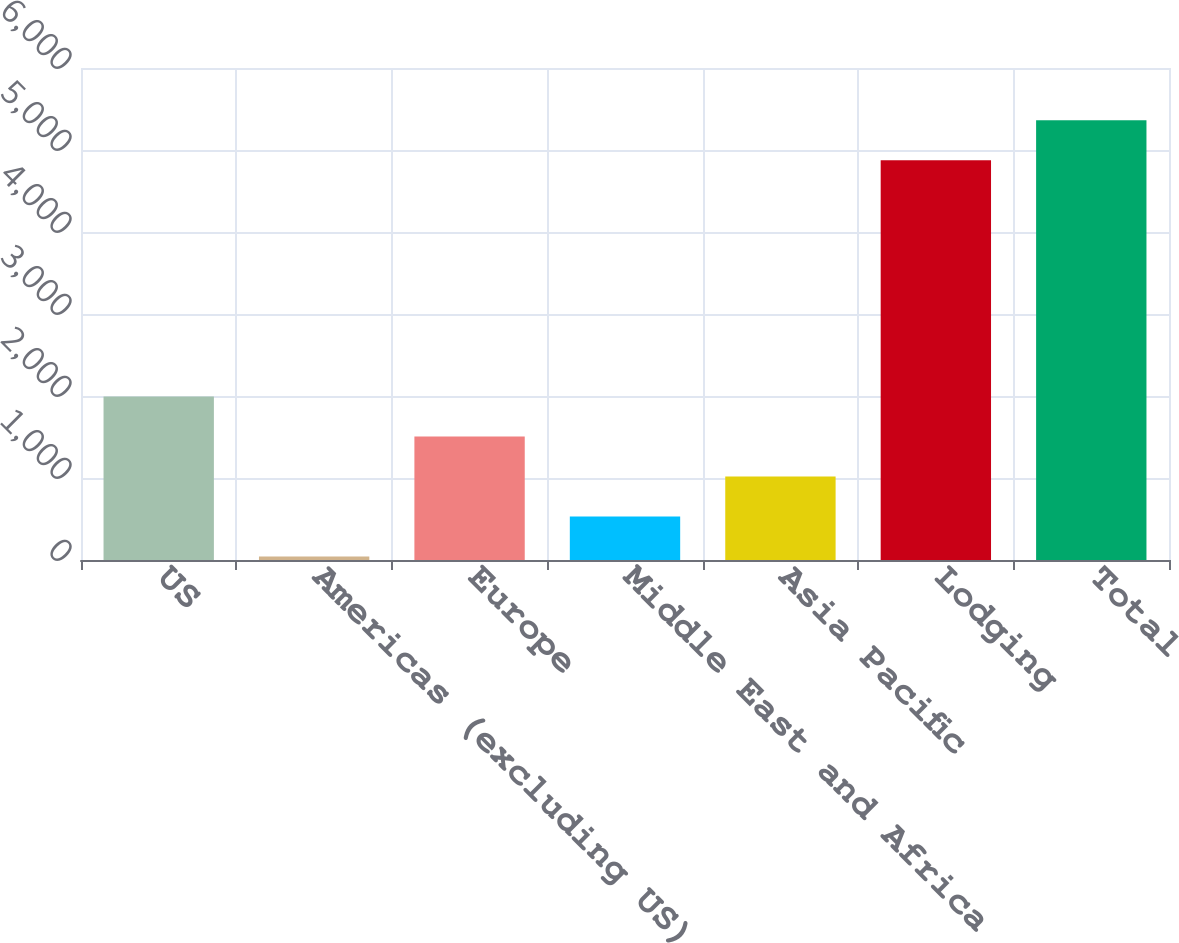Convert chart to OTSL. <chart><loc_0><loc_0><loc_500><loc_500><bar_chart><fcel>US<fcel>Americas (excluding US)<fcel>Europe<fcel>Middle East and Africa<fcel>Asia Pacific<fcel>Lodging<fcel>Total<nl><fcel>1994.6<fcel>43<fcel>1506.7<fcel>530.9<fcel>1018.8<fcel>4875<fcel>5362.9<nl></chart> 